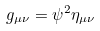Convert formula to latex. <formula><loc_0><loc_0><loc_500><loc_500>g _ { \mu \nu } = \psi ^ { 2 } \eta _ { \mu \nu }</formula> 